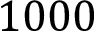<formula> <loc_0><loc_0><loc_500><loc_500>1 0 0 0</formula> 